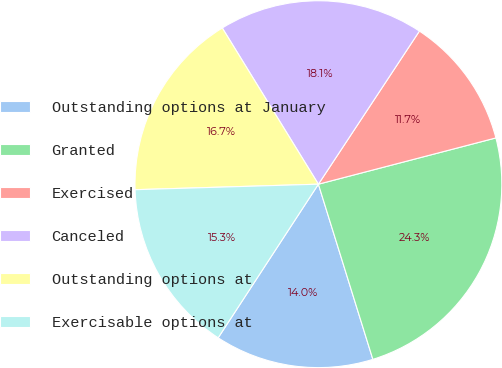<chart> <loc_0><loc_0><loc_500><loc_500><pie_chart><fcel>Outstanding options at January<fcel>Granted<fcel>Exercised<fcel>Canceled<fcel>Outstanding options at<fcel>Exercisable options at<nl><fcel>14.0%<fcel>24.26%<fcel>11.66%<fcel>18.06%<fcel>16.7%<fcel>15.32%<nl></chart> 